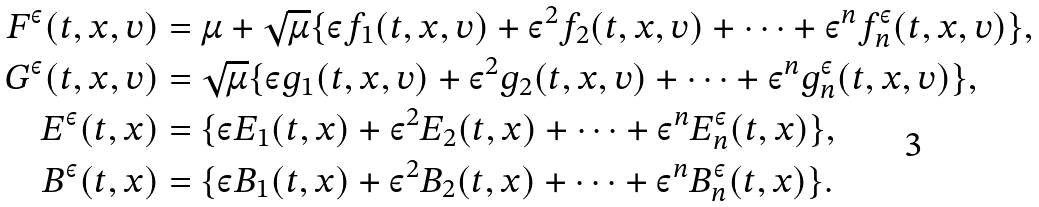Convert formula to latex. <formula><loc_0><loc_0><loc_500><loc_500>F ^ { \varepsilon } ( t , x , v ) & = \mu + \sqrt { \mu } \{ \varepsilon f _ { 1 } ( t , x , v ) + \varepsilon ^ { 2 } f _ { 2 } ( t , x , v ) + \dots + \varepsilon ^ { n } f _ { n } ^ { \varepsilon } ( t , x , v ) \} , \\ G ^ { \varepsilon } ( t , x , v ) & = \sqrt { \mu } \{ \varepsilon g _ { 1 } ( t , x , v ) + \varepsilon ^ { 2 } g _ { 2 } ( t , x , v ) + \dots + \varepsilon ^ { n } g _ { n } ^ { \varepsilon } ( t , x , v ) \} , \\ E ^ { \varepsilon } ( t , x ) & = \{ \varepsilon E _ { 1 } ( t , x ) + \varepsilon ^ { 2 } E _ { 2 } ( t , x ) + \dots + \varepsilon ^ { n } E _ { n } ^ { \varepsilon } ( t , x ) \} , \\ B ^ { \varepsilon } ( t , x ) & = \{ \varepsilon B _ { 1 } ( t , x ) + \varepsilon ^ { 2 } B _ { 2 } ( t , x ) + \dots + \varepsilon ^ { n } B _ { n } ^ { \varepsilon } ( t , x ) \} .</formula> 